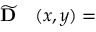Convert formula to latex. <formula><loc_0><loc_0><loc_500><loc_500>\begin{array} { r l } { \widetilde { D } } & ( x , y ) = } \end{array}</formula> 